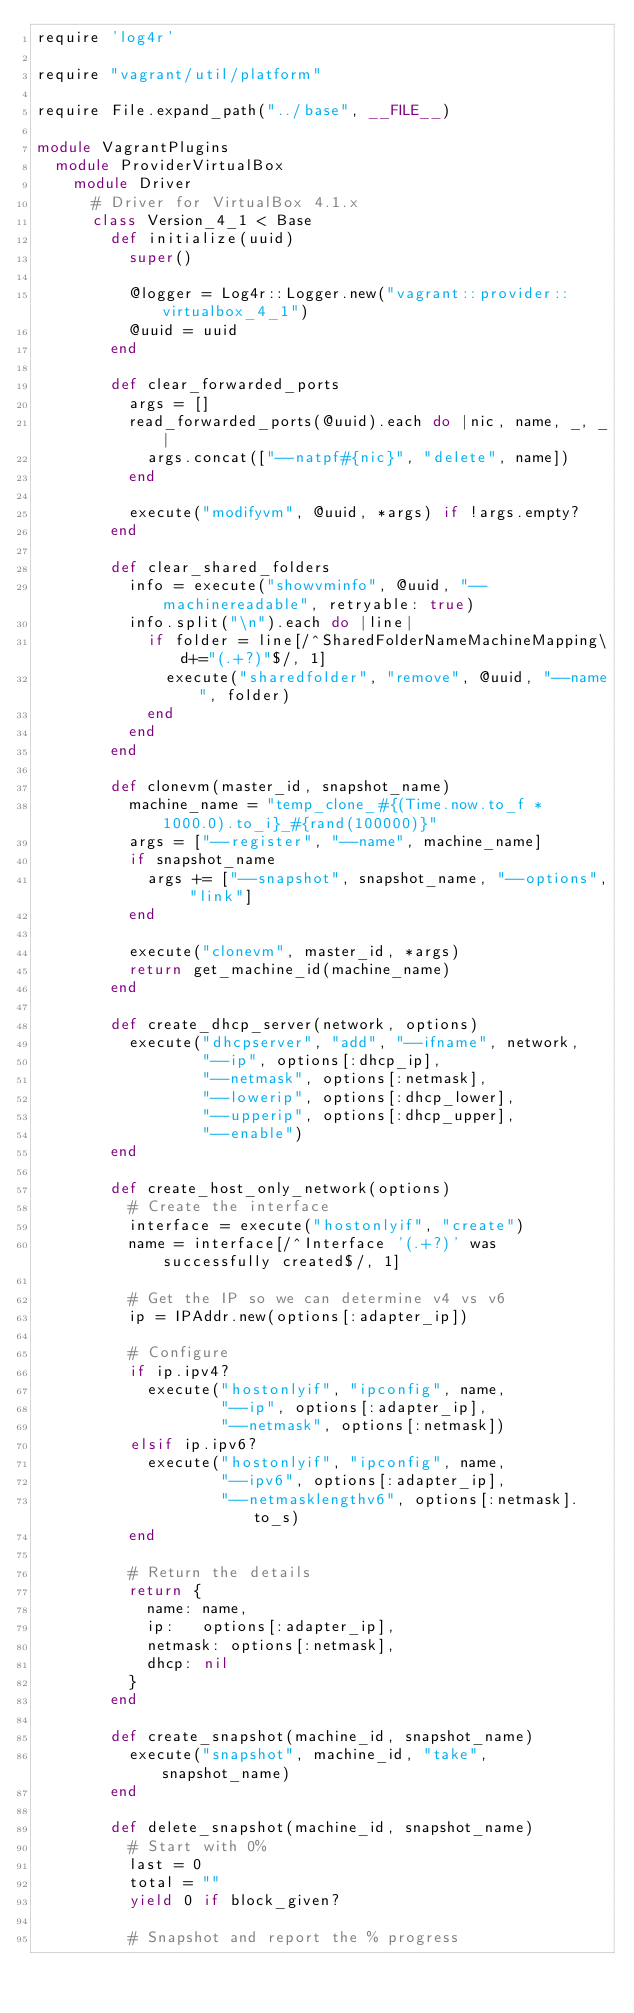Convert code to text. <code><loc_0><loc_0><loc_500><loc_500><_Ruby_>require 'log4r'

require "vagrant/util/platform"

require File.expand_path("../base", __FILE__)

module VagrantPlugins
  module ProviderVirtualBox
    module Driver
      # Driver for VirtualBox 4.1.x
      class Version_4_1 < Base
        def initialize(uuid)
          super()

          @logger = Log4r::Logger.new("vagrant::provider::virtualbox_4_1")
          @uuid = uuid
        end

        def clear_forwarded_ports
          args = []
          read_forwarded_ports(@uuid).each do |nic, name, _, _|
            args.concat(["--natpf#{nic}", "delete", name])
          end

          execute("modifyvm", @uuid, *args) if !args.empty?
        end

        def clear_shared_folders
          info = execute("showvminfo", @uuid, "--machinereadable", retryable: true)
          info.split("\n").each do |line|
            if folder = line[/^SharedFolderNameMachineMapping\d+="(.+?)"$/, 1]
              execute("sharedfolder", "remove", @uuid, "--name", folder)
            end
          end
        end

        def clonevm(master_id, snapshot_name)
          machine_name = "temp_clone_#{(Time.now.to_f * 1000.0).to_i}_#{rand(100000)}"
          args = ["--register", "--name", machine_name]
          if snapshot_name
            args += ["--snapshot", snapshot_name, "--options", "link"]
          end

          execute("clonevm", master_id, *args)
          return get_machine_id(machine_name)
        end

        def create_dhcp_server(network, options)
          execute("dhcpserver", "add", "--ifname", network,
                  "--ip", options[:dhcp_ip],
                  "--netmask", options[:netmask],
                  "--lowerip", options[:dhcp_lower],
                  "--upperip", options[:dhcp_upper],
                  "--enable")
        end

        def create_host_only_network(options)
          # Create the interface
          interface = execute("hostonlyif", "create")
          name = interface[/^Interface '(.+?)' was successfully created$/, 1]

          # Get the IP so we can determine v4 vs v6
          ip = IPAddr.new(options[:adapter_ip])

          # Configure
          if ip.ipv4?
            execute("hostonlyif", "ipconfig", name,
                    "--ip", options[:adapter_ip],
                    "--netmask", options[:netmask])
          elsif ip.ipv6?
            execute("hostonlyif", "ipconfig", name,
                    "--ipv6", options[:adapter_ip],
                    "--netmasklengthv6", options[:netmask].to_s)
          end

          # Return the details
          return {
            name: name,
            ip:   options[:adapter_ip],
            netmask: options[:netmask],
            dhcp: nil
          }
        end

        def create_snapshot(machine_id, snapshot_name)
          execute("snapshot", machine_id, "take", snapshot_name)
        end

        def delete_snapshot(machine_id, snapshot_name)
          # Start with 0%
          last = 0
          total = ""
          yield 0 if block_given?

          # Snapshot and report the % progress</code> 